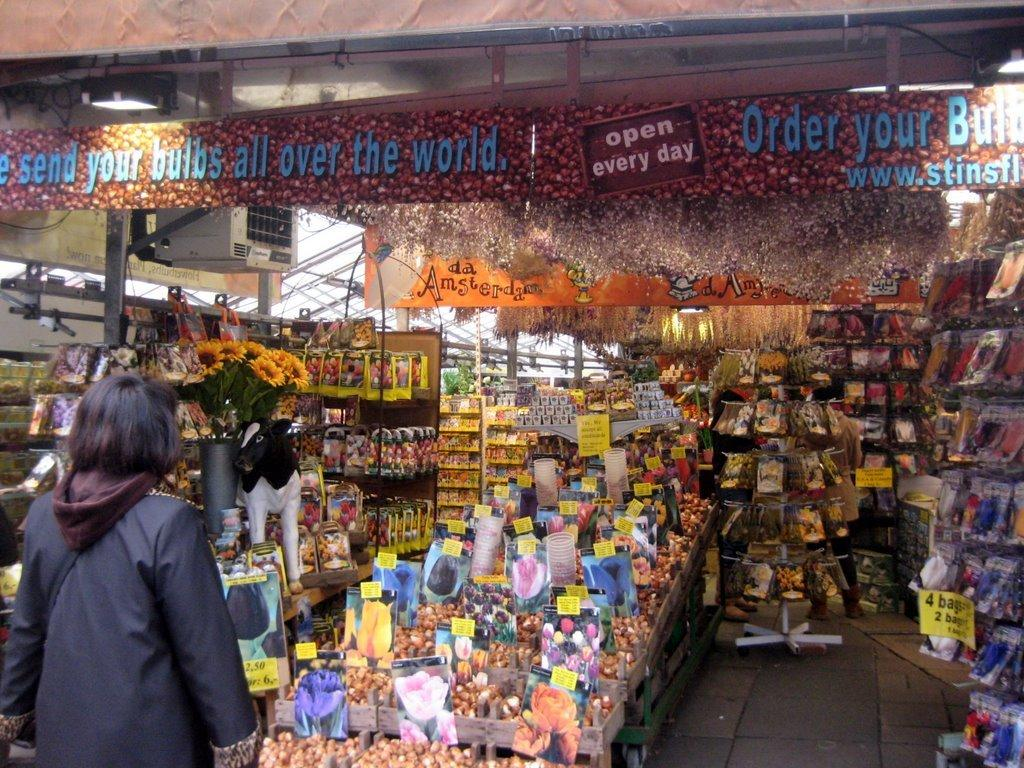<image>
Describe the image concisely. A sign hanging from the ceiling of a store informs that the store is open every day. 